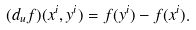Convert formula to latex. <formula><loc_0><loc_0><loc_500><loc_500>( d _ { u } f ) ( x ^ { i } , y ^ { i } ) = f ( y ^ { i } ) - f ( x ^ { i } ) .</formula> 